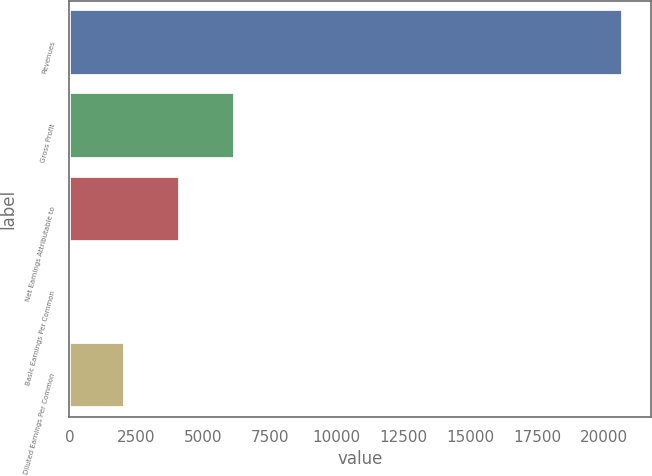Convert chart. <chart><loc_0><loc_0><loc_500><loc_500><bar_chart><fcel>Revenues<fcel>Gross Profit<fcel>Net Earnings Attributable to<fcel>Basic Earnings Per Common<fcel>Diluted Earnings Per Common<nl><fcel>20696<fcel>6209.08<fcel>4139.52<fcel>0.4<fcel>2069.96<nl></chart> 